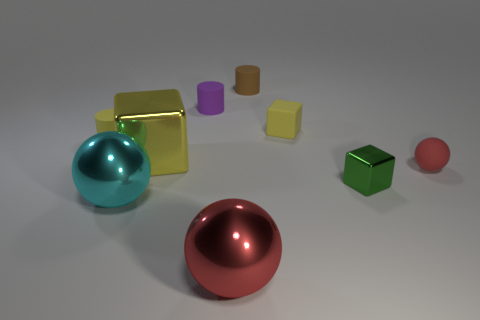There is a red sphere that is on the left side of the shiny block in front of the yellow metallic cube; what size is it?
Your answer should be compact. Large. How many cyan spheres are the same size as the cyan metal thing?
Give a very brief answer. 0. Is the color of the small object that is behind the tiny purple thing the same as the large ball that is right of the cyan shiny ball?
Offer a very short reply. No. There is a green metallic object; are there any tiny rubber blocks to the left of it?
Ensure brevity in your answer.  Yes. There is a large object that is both in front of the yellow metallic thing and right of the big cyan ball; what color is it?
Provide a succinct answer. Red. Are there any tiny metallic balls that have the same color as the large metallic cube?
Give a very brief answer. No. Are the big thing that is behind the small sphere and the red object to the left of the red matte sphere made of the same material?
Your answer should be very brief. Yes. There is a red rubber sphere in front of the tiny purple matte cylinder; what size is it?
Offer a very short reply. Small. The brown object has what size?
Your answer should be very brief. Small. There is a metal thing that is on the right side of the red ball that is in front of the large cyan metallic sphere left of the tiny metal thing; how big is it?
Give a very brief answer. Small. 